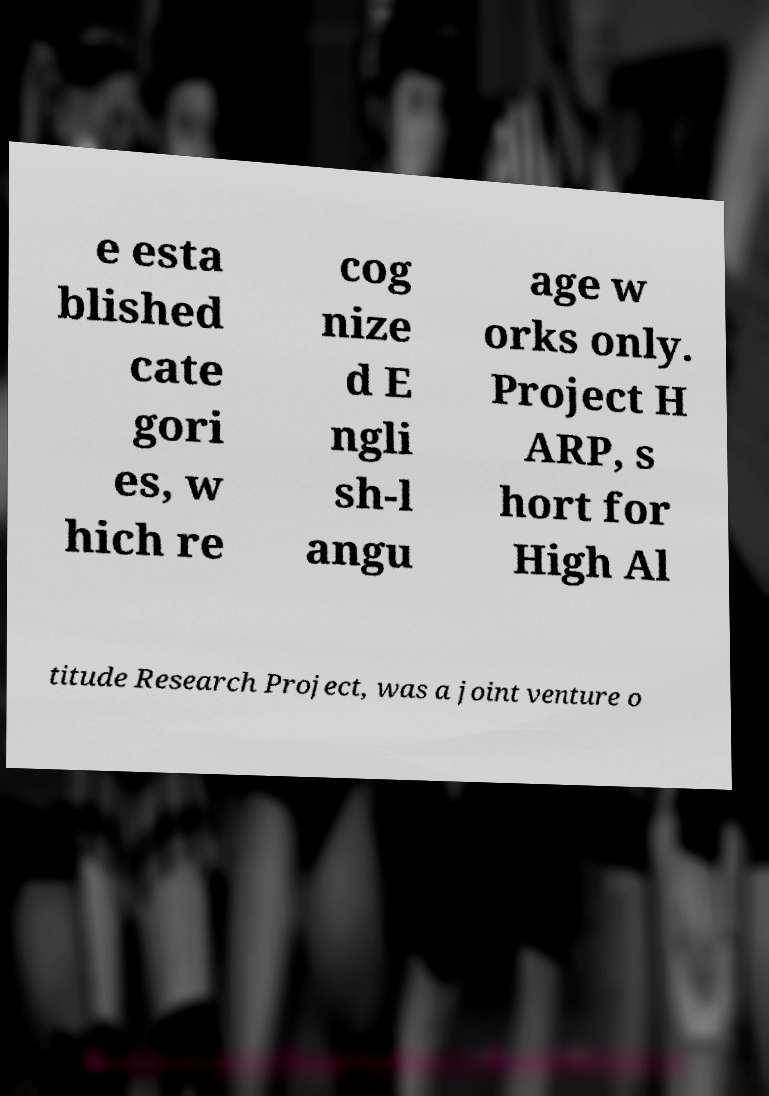Can you accurately transcribe the text from the provided image for me? e esta blished cate gori es, w hich re cog nize d E ngli sh-l angu age w orks only. Project H ARP, s hort for High Al titude Research Project, was a joint venture o 